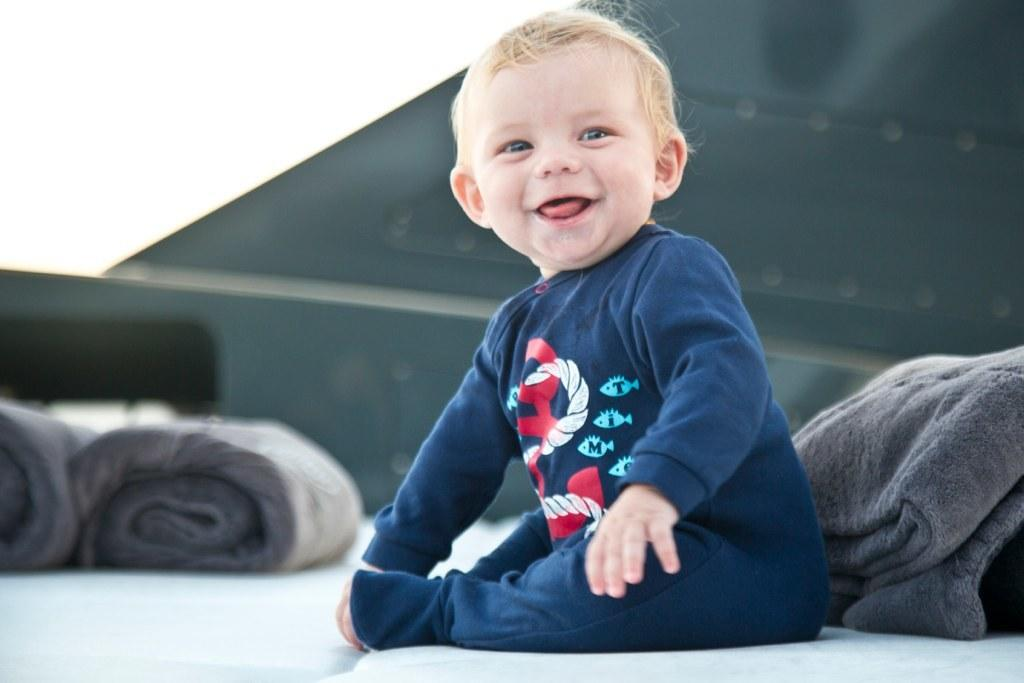What is the main subject of the picture? The main subject of the picture is a baby. What is the baby doing in the picture? The baby is sitting on a surface and smiling. What can be seen behind the baby? There is a bed sheet behind the baby. How would you describe the background of the image? The background of the image is blurry. Can you tell me where the beggar is standing in the image? There is no beggar present in the image; it features a baby sitting on a surface. How many sisters does the baby have in the image? There is no information about the baby's sisters in the image. 